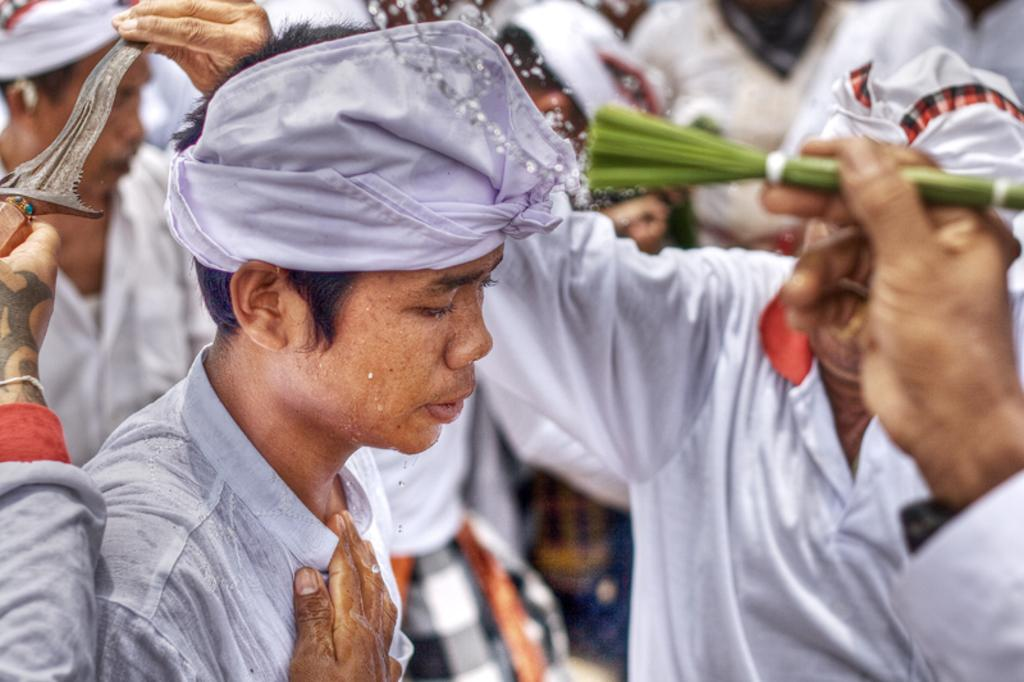What is the main subject of the image? There is a person in the image. What is the person wearing on their head? The person is wearing a cloth on their head. What can be seen on the left side of the image? There is a person's hand holding a knife on the left side of the image. What is the person on the right side of the image holding? The person on the right side is holding leaves. What type of brass instrument is being played by the person in the image? There is no brass instrument present in the image. How does the person adjust the water flow in the image? There is no water or adjustment of water flow in the image. 